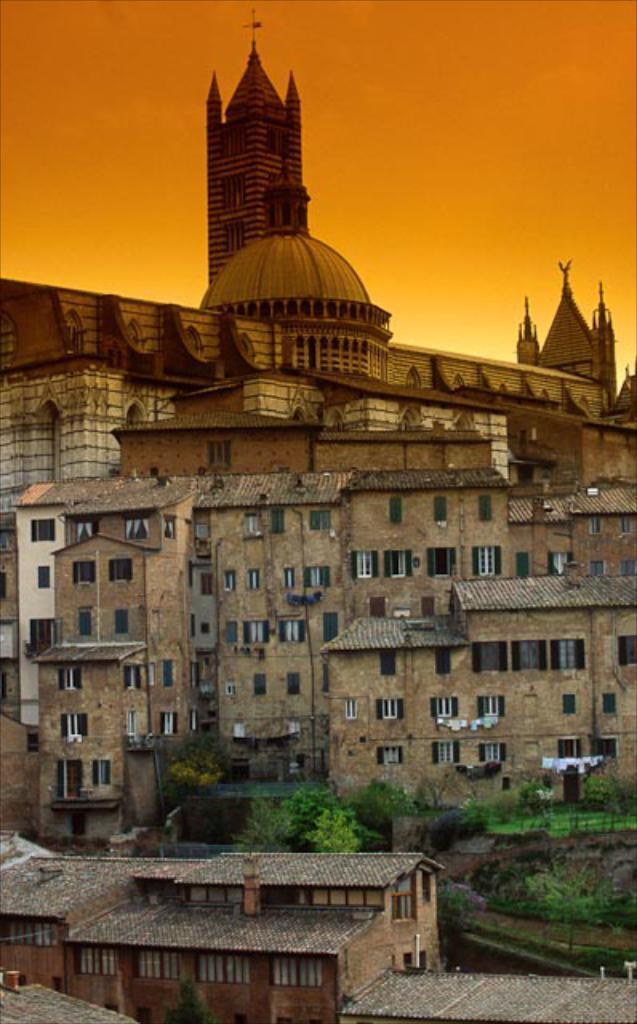What type of structures are present in the image? There are buildings in the image. What are the main features of these buildings? The buildings have walls, windows, and roofs. What other elements can be seen in the image besides the buildings? There are trees in the image. What is visible at the top of the image? The sky is visible at the top of the image. Can you see an uncle walking with a yoke in the image? There is no uncle or yoke present in the image. 